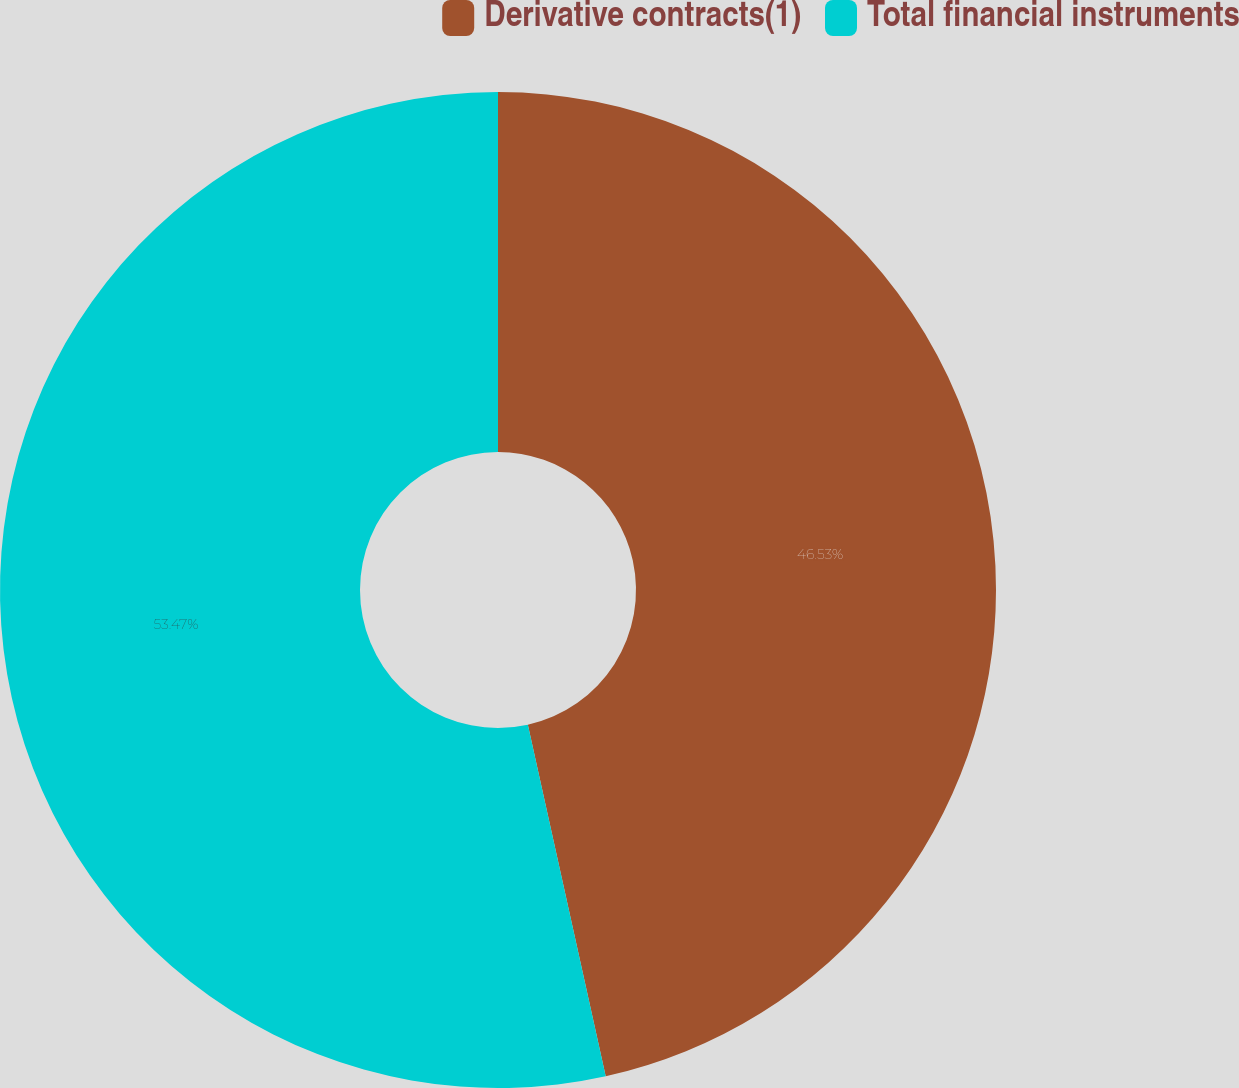<chart> <loc_0><loc_0><loc_500><loc_500><pie_chart><fcel>Derivative contracts(1)<fcel>Total financial instruments<nl><fcel>46.53%<fcel>53.47%<nl></chart> 